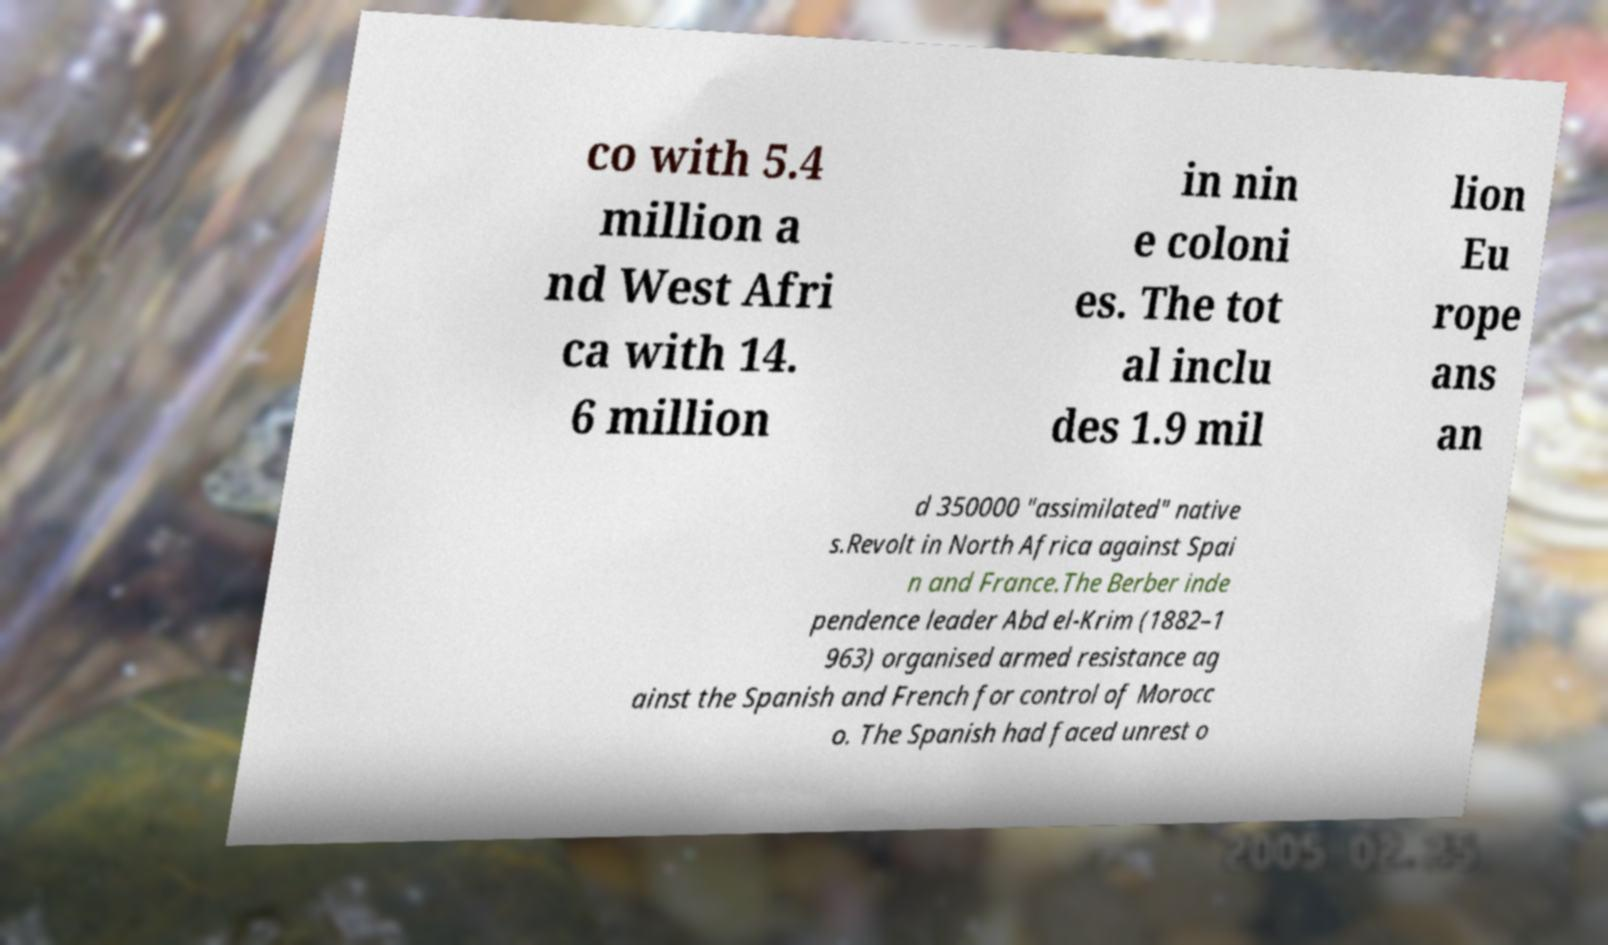For documentation purposes, I need the text within this image transcribed. Could you provide that? co with 5.4 million a nd West Afri ca with 14. 6 million in nin e coloni es. The tot al inclu des 1.9 mil lion Eu rope ans an d 350000 "assimilated" native s.Revolt in North Africa against Spai n and France.The Berber inde pendence leader Abd el-Krim (1882–1 963) organised armed resistance ag ainst the Spanish and French for control of Morocc o. The Spanish had faced unrest o 